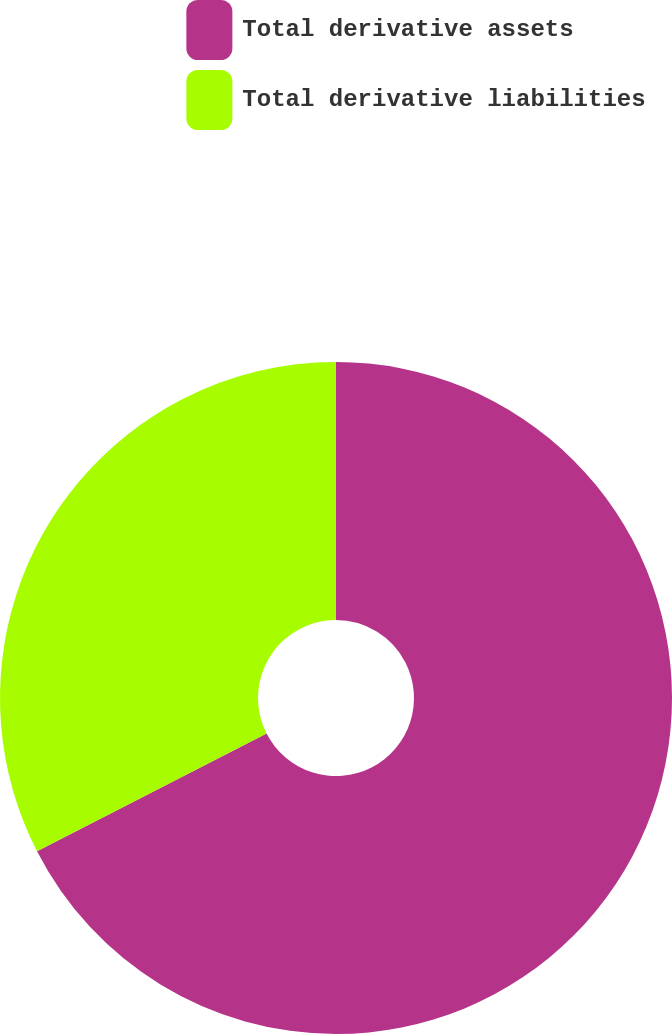<chart> <loc_0><loc_0><loc_500><loc_500><pie_chart><fcel>Total derivative assets<fcel>Total derivative liabilities<nl><fcel>67.46%<fcel>32.54%<nl></chart> 